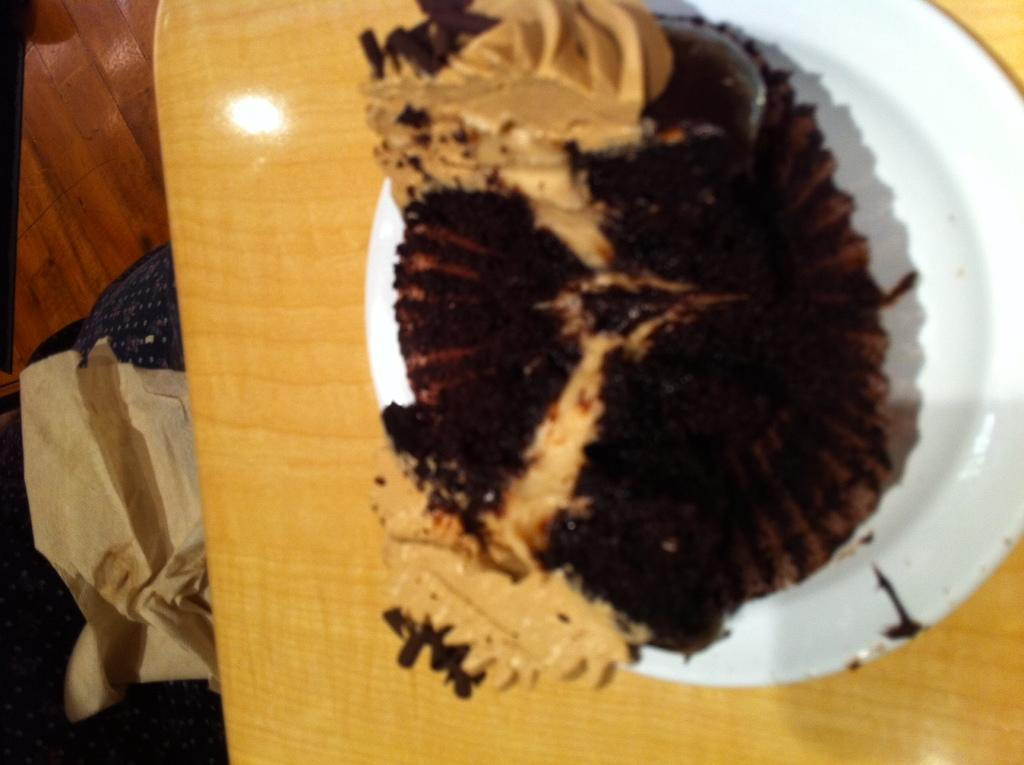What is present on the plate in the image? There is food on the plate in the image. Where is the plate and food located? The plate and food are on a platform. What type of surface is the platform made of? The facts provided do not specify the material of the platform. How many spiders are crawling on the food in the image? There are no spiders present in the image; it only shows a plate with food on a platform. 